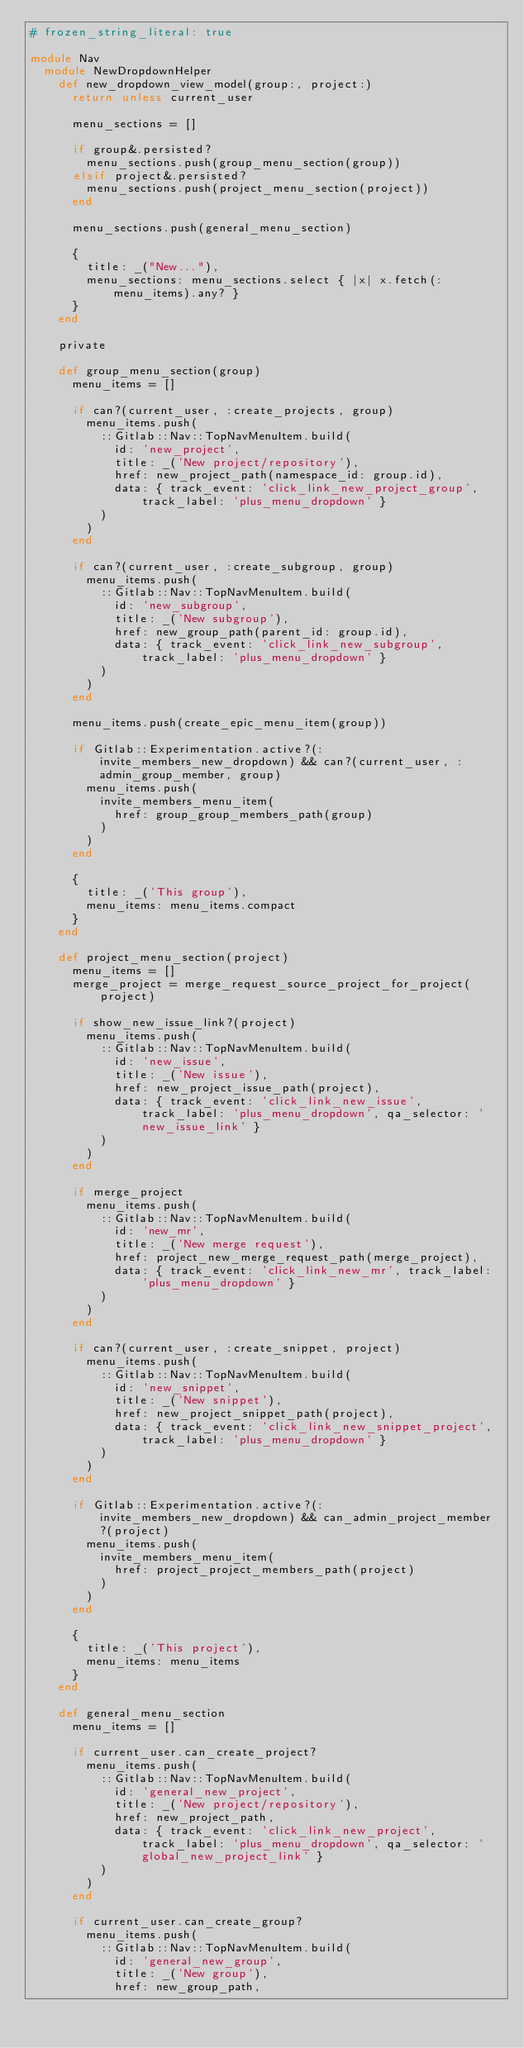<code> <loc_0><loc_0><loc_500><loc_500><_Ruby_># frozen_string_literal: true

module Nav
  module NewDropdownHelper
    def new_dropdown_view_model(group:, project:)
      return unless current_user

      menu_sections = []

      if group&.persisted?
        menu_sections.push(group_menu_section(group))
      elsif project&.persisted?
        menu_sections.push(project_menu_section(project))
      end

      menu_sections.push(general_menu_section)

      {
        title: _("New..."),
        menu_sections: menu_sections.select { |x| x.fetch(:menu_items).any? }
      }
    end

    private

    def group_menu_section(group)
      menu_items = []

      if can?(current_user, :create_projects, group)
        menu_items.push(
          ::Gitlab::Nav::TopNavMenuItem.build(
            id: 'new_project',
            title: _('New project/repository'),
            href: new_project_path(namespace_id: group.id),
            data: { track_event: 'click_link_new_project_group', track_label: 'plus_menu_dropdown' }
          )
        )
      end

      if can?(current_user, :create_subgroup, group)
        menu_items.push(
          ::Gitlab::Nav::TopNavMenuItem.build(
            id: 'new_subgroup',
            title: _('New subgroup'),
            href: new_group_path(parent_id: group.id),
            data: { track_event: 'click_link_new_subgroup', track_label: 'plus_menu_dropdown' }
          )
        )
      end

      menu_items.push(create_epic_menu_item(group))

      if Gitlab::Experimentation.active?(:invite_members_new_dropdown) && can?(current_user, :admin_group_member, group)
        menu_items.push(
          invite_members_menu_item(
            href: group_group_members_path(group)
          )
        )
      end

      {
        title: _('This group'),
        menu_items: menu_items.compact
      }
    end

    def project_menu_section(project)
      menu_items = []
      merge_project = merge_request_source_project_for_project(project)

      if show_new_issue_link?(project)
        menu_items.push(
          ::Gitlab::Nav::TopNavMenuItem.build(
            id: 'new_issue',
            title: _('New issue'),
            href: new_project_issue_path(project),
            data: { track_event: 'click_link_new_issue', track_label: 'plus_menu_dropdown', qa_selector: 'new_issue_link' }
          )
        )
      end

      if merge_project
        menu_items.push(
          ::Gitlab::Nav::TopNavMenuItem.build(
            id: 'new_mr',
            title: _('New merge request'),
            href: project_new_merge_request_path(merge_project),
            data: { track_event: 'click_link_new_mr', track_label: 'plus_menu_dropdown' }
          )
        )
      end

      if can?(current_user, :create_snippet, project)
        menu_items.push(
          ::Gitlab::Nav::TopNavMenuItem.build(
            id: 'new_snippet',
            title: _('New snippet'),
            href: new_project_snippet_path(project),
            data: { track_event: 'click_link_new_snippet_project', track_label: 'plus_menu_dropdown' }
          )
        )
      end

      if Gitlab::Experimentation.active?(:invite_members_new_dropdown) && can_admin_project_member?(project)
        menu_items.push(
          invite_members_menu_item(
            href: project_project_members_path(project)
          )
        )
      end

      {
        title: _('This project'),
        menu_items: menu_items
      }
    end

    def general_menu_section
      menu_items = []

      if current_user.can_create_project?
        menu_items.push(
          ::Gitlab::Nav::TopNavMenuItem.build(
            id: 'general_new_project',
            title: _('New project/repository'),
            href: new_project_path,
            data: { track_event: 'click_link_new_project', track_label: 'plus_menu_dropdown', qa_selector: 'global_new_project_link' }
          )
        )
      end

      if current_user.can_create_group?
        menu_items.push(
          ::Gitlab::Nav::TopNavMenuItem.build(
            id: 'general_new_group',
            title: _('New group'),
            href: new_group_path,</code> 